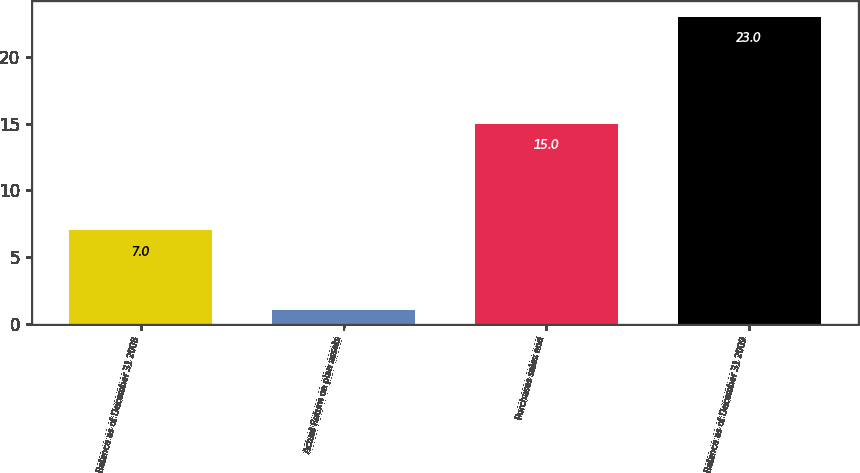Convert chart to OTSL. <chart><loc_0><loc_0><loc_500><loc_500><bar_chart><fcel>Balance as of December 31 2008<fcel>Actual Return on plan assets<fcel>Purchases sales and<fcel>Balance as of December 31 2009<nl><fcel>7<fcel>1<fcel>15<fcel>23<nl></chart> 